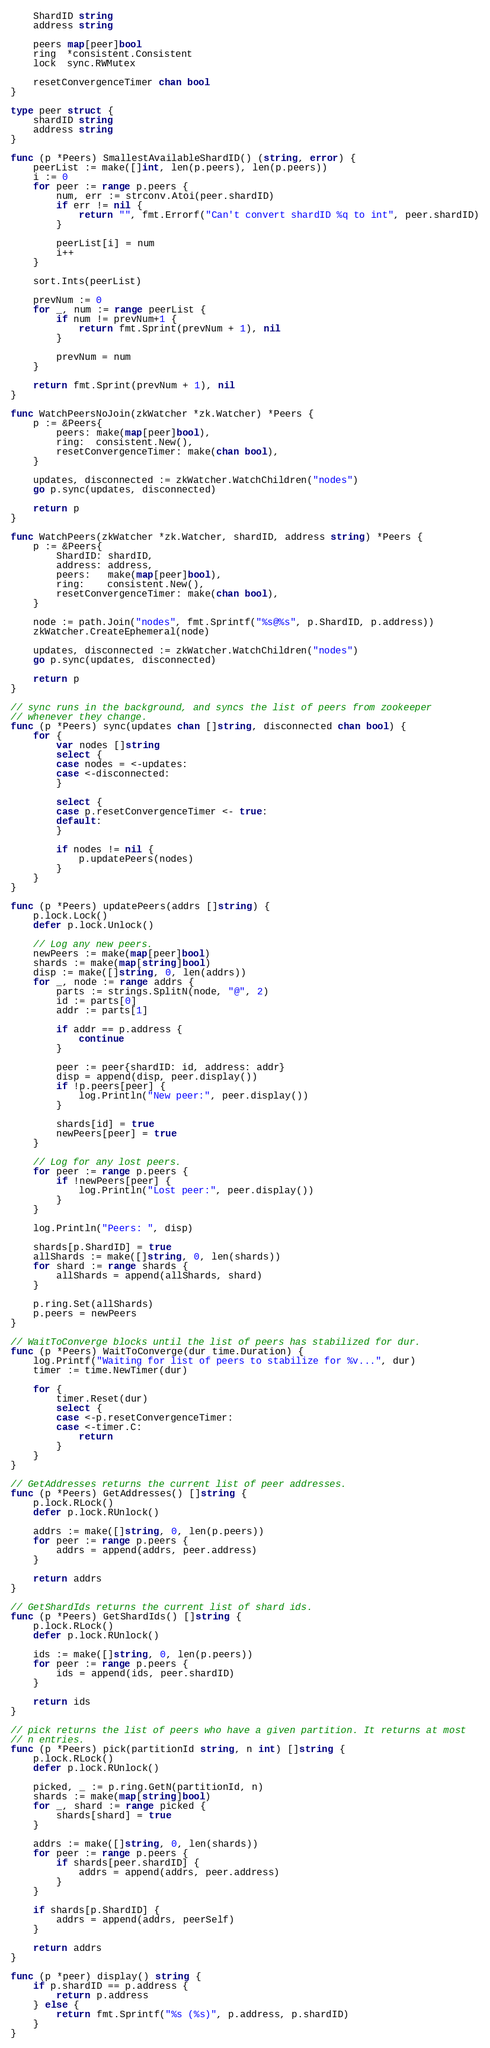Convert code to text. <code><loc_0><loc_0><loc_500><loc_500><_Go_>	ShardID string
	address string

	peers map[peer]bool
	ring  *consistent.Consistent
	lock  sync.RWMutex

	resetConvergenceTimer chan bool
}

type peer struct {
	shardID string
	address string
}

func (p *Peers) SmallestAvailableShardID() (string, error) {
	peerList := make([]int, len(p.peers), len(p.peers))
	i := 0
	for peer := range p.peers {
		num, err := strconv.Atoi(peer.shardID)
		if err != nil {
			return "", fmt.Errorf("Can't convert shardID %q to int", peer.shardID)
		}

		peerList[i] = num
		i++
	}

	sort.Ints(peerList)

	prevNum := 0
	for _, num := range peerList {
		if num != prevNum+1 {
			return fmt.Sprint(prevNum + 1), nil
		}

		prevNum = num
	}

	return fmt.Sprint(prevNum + 1), nil
}

func WatchPeersNoJoin(zkWatcher *zk.Watcher) *Peers {
	p := &Peers{
		peers: make(map[peer]bool),
		ring:  consistent.New(),
		resetConvergenceTimer: make(chan bool),
	}

	updates, disconnected := zkWatcher.WatchChildren("nodes")
	go p.sync(updates, disconnected)

	return p
}

func WatchPeers(zkWatcher *zk.Watcher, shardID, address string) *Peers {
	p := &Peers{
		ShardID: shardID,
		address: address,
		peers:   make(map[peer]bool),
		ring:    consistent.New(),
		resetConvergenceTimer: make(chan bool),
	}

	node := path.Join("nodes", fmt.Sprintf("%s@%s", p.ShardID, p.address))
	zkWatcher.CreateEphemeral(node)

	updates, disconnected := zkWatcher.WatchChildren("nodes")
	go p.sync(updates, disconnected)

	return p
}

// sync runs in the background, and syncs the list of peers from zookeeper
// whenever they change.
func (p *Peers) sync(updates chan []string, disconnected chan bool) {
	for {
		var nodes []string
		select {
		case nodes = <-updates:
		case <-disconnected:
		}

		select {
		case p.resetConvergenceTimer <- true:
		default:
		}

		if nodes != nil {
			p.updatePeers(nodes)
		}
	}
}

func (p *Peers) updatePeers(addrs []string) {
	p.lock.Lock()
	defer p.lock.Unlock()

	// Log any new peers.
	newPeers := make(map[peer]bool)
	shards := make(map[string]bool)
	disp := make([]string, 0, len(addrs))
	for _, node := range addrs {
		parts := strings.SplitN(node, "@", 2)
		id := parts[0]
		addr := parts[1]

		if addr == p.address {
			continue
		}

		peer := peer{shardID: id, address: addr}
		disp = append(disp, peer.display())
		if !p.peers[peer] {
			log.Println("New peer:", peer.display())
		}

		shards[id] = true
		newPeers[peer] = true
	}

	// Log for any lost peers.
	for peer := range p.peers {
		if !newPeers[peer] {
			log.Println("Lost peer:", peer.display())
		}
	}

	log.Println("Peers: ", disp)

	shards[p.ShardID] = true
	allShards := make([]string, 0, len(shards))
	for shard := range shards {
		allShards = append(allShards, shard)
	}

	p.ring.Set(allShards)
	p.peers = newPeers
}

// WaitToConverge blocks until the list of peers has stabilized for dur.
func (p *Peers) WaitToConverge(dur time.Duration) {
	log.Printf("Waiting for list of peers to stabilize for %v...", dur)
	timer := time.NewTimer(dur)

	for {
		timer.Reset(dur)
		select {
		case <-p.resetConvergenceTimer:
		case <-timer.C:
			return
		}
	}
}

// GetAddresses returns the current list of peer addresses.
func (p *Peers) GetAddresses() []string {
	p.lock.RLock()
	defer p.lock.RUnlock()

	addrs := make([]string, 0, len(p.peers))
	for peer := range p.peers {
		addrs = append(addrs, peer.address)
	}

	return addrs
}

// GetShardIds returns the current list of shard ids.
func (p *Peers) GetShardIds() []string {
	p.lock.RLock()
	defer p.lock.RUnlock()

	ids := make([]string, 0, len(p.peers))
	for peer := range p.peers {
		ids = append(ids, peer.shardID)
	}

	return ids
}

// pick returns the list of peers who have a given partition. It returns at most
// n entries.
func (p *Peers) pick(partitionId string, n int) []string {
	p.lock.RLock()
	defer p.lock.RUnlock()

	picked, _ := p.ring.GetN(partitionId, n)
	shards := make(map[string]bool)
	for _, shard := range picked {
		shards[shard] = true
	}

	addrs := make([]string, 0, len(shards))
	for peer := range p.peers {
		if shards[peer.shardID] {
			addrs = append(addrs, peer.address)
		}
	}

	if shards[p.ShardID] {
		addrs = append(addrs, peerSelf)
	}

	return addrs
}

func (p *peer) display() string {
	if p.shardID == p.address {
		return p.address
	} else {
		return fmt.Sprintf("%s (%s)", p.address, p.shardID)
	}
}
</code> 